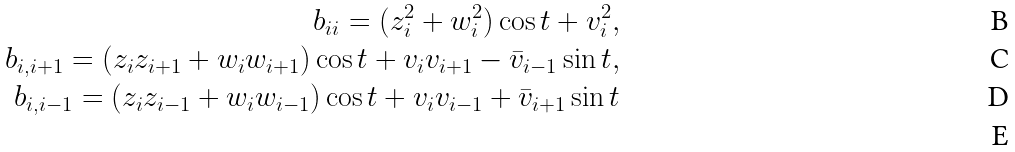<formula> <loc_0><loc_0><loc_500><loc_500>b _ { i i } = ( z _ { i } ^ { 2 } + w _ { i } ^ { 2 } ) \cos t + v _ { i } ^ { 2 } , \\ b _ { i , i + 1 } = ( z _ { i } z _ { i + 1 } + w _ { i } w _ { i + 1 } ) \cos t + v _ { i } v _ { i + 1 } - \bar { v } _ { i - 1 } \sin t , \\ b _ { i , i - 1 } = ( z _ { i } z _ { i - 1 } + w _ { i } w _ { i - 1 } ) \cos t + v _ { i } v _ { i - 1 } + \bar { v } _ { i + 1 } \sin t \\</formula> 